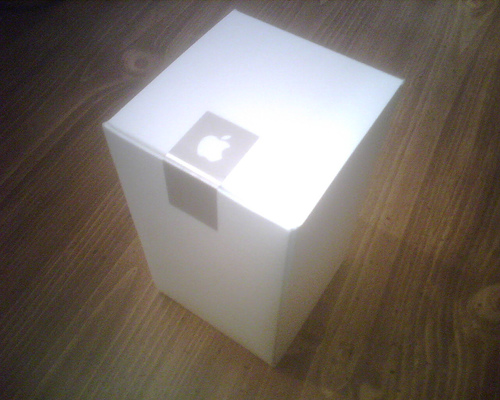<image>
Can you confirm if the box is next to the logo? No. The box is not positioned next to the logo. They are located in different areas of the scene. 